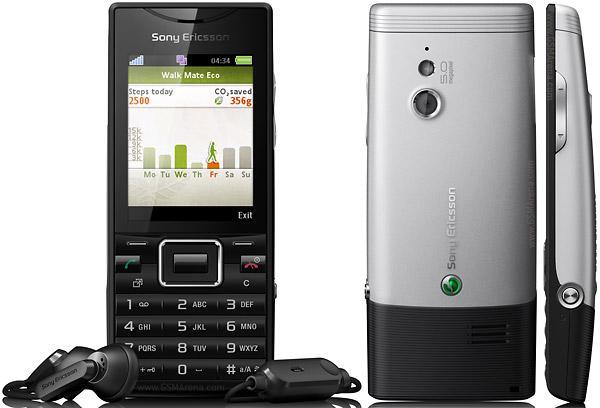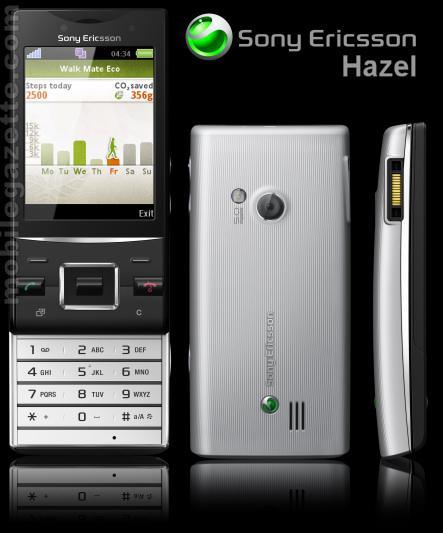The first image is the image on the left, the second image is the image on the right. Analyze the images presented: Is the assertion "The left and right image contains the same number of phones." valid? Answer yes or no. Yes. 